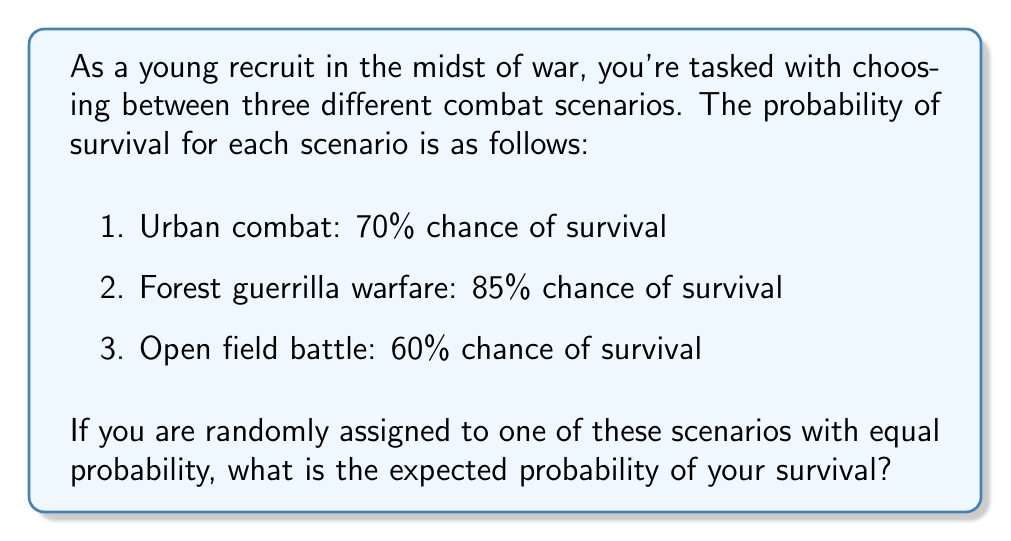Can you solve this math problem? To solve this problem, we need to calculate the expected value of the probability of survival. Let's approach this step-by-step:

1. Define the random variable:
   Let $X$ be the probability of survival in a randomly chosen scenario.

2. Identify the possible values of $X$ and their probabilities:
   $P(X = 0.70) = \frac{1}{3}$ (Urban combat)
   $P(X = 0.85) = \frac{1}{3}$ (Forest guerrilla warfare)
   $P(X = 0.60) = \frac{1}{3}$ (Open field battle)

3. Calculate the expected value using the formula:
   $$E(X) = \sum_{i=1}^{n} x_i \cdot P(X = x_i)$$

   Where $x_i$ are the possible values of $X$, and $P(X = x_i)$ are their respective probabilities.

4. Plug in the values:
   $$E(X) = 0.70 \cdot \frac{1}{3} + 0.85 \cdot \frac{1}{3} + 0.60 \cdot \frac{1}{3}$$

5. Simplify:
   $$E(X) = \frac{0.70 + 0.85 + 0.60}{3} = \frac{2.15}{3} \approx 0.7167$$

Therefore, the expected probability of survival is approximately 0.7167 or 71.67%.
Answer: 0.7167 or 71.67% 